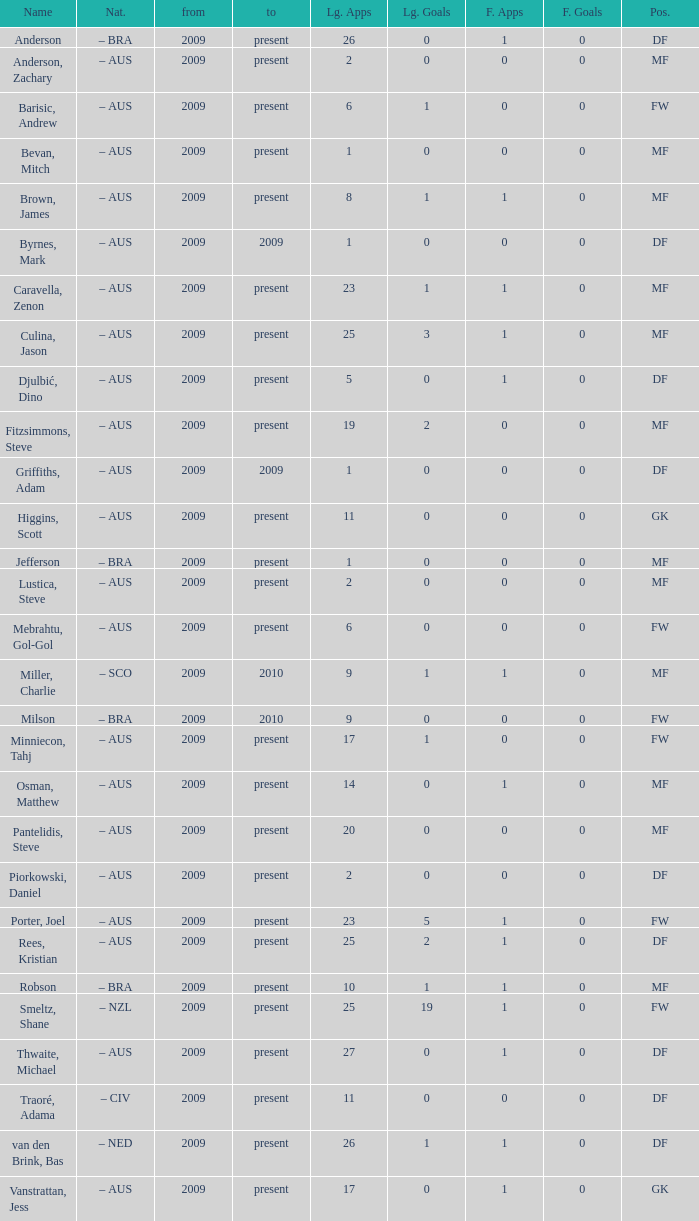Name the mosst finals apps 1.0. 